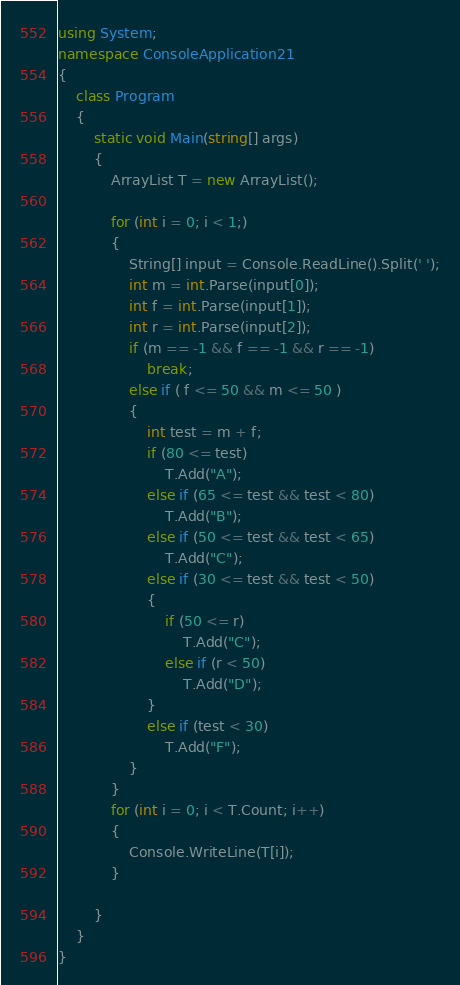<code> <loc_0><loc_0><loc_500><loc_500><_C#_>using System;
namespace ConsoleApplication21
{
    class Program
    {
        static void Main(string[] args)
        {
            ArrayList T = new ArrayList();

            for (int i = 0; i < 1;)
            {
                String[] input = Console.ReadLine().Split(' ');
                int m = int.Parse(input[0]);
                int f = int.Parse(input[1]);
                int r = int.Parse(input[2]);
                if (m == -1 && f == -1 && r == -1)
                    break;
                else if ( f <= 50 && m <= 50 )
                {
                    int test = m + f;
                    if (80 <= test)
                        T.Add("A");
                    else if (65 <= test && test < 80)
                        T.Add("B");
                    else if (50 <= test && test < 65)
                        T.Add("C");
                    else if (30 <= test && test < 50)
                    {
                        if (50 <= r)
                            T.Add("C");
                        else if (r < 50)
                            T.Add("D");
                    }
                    else if (test < 30)
                        T.Add("F");
                }
            }
            for (int i = 0; i < T.Count; i++)
            {
                Console.WriteLine(T[i]);
            }

        }
    }
}</code> 